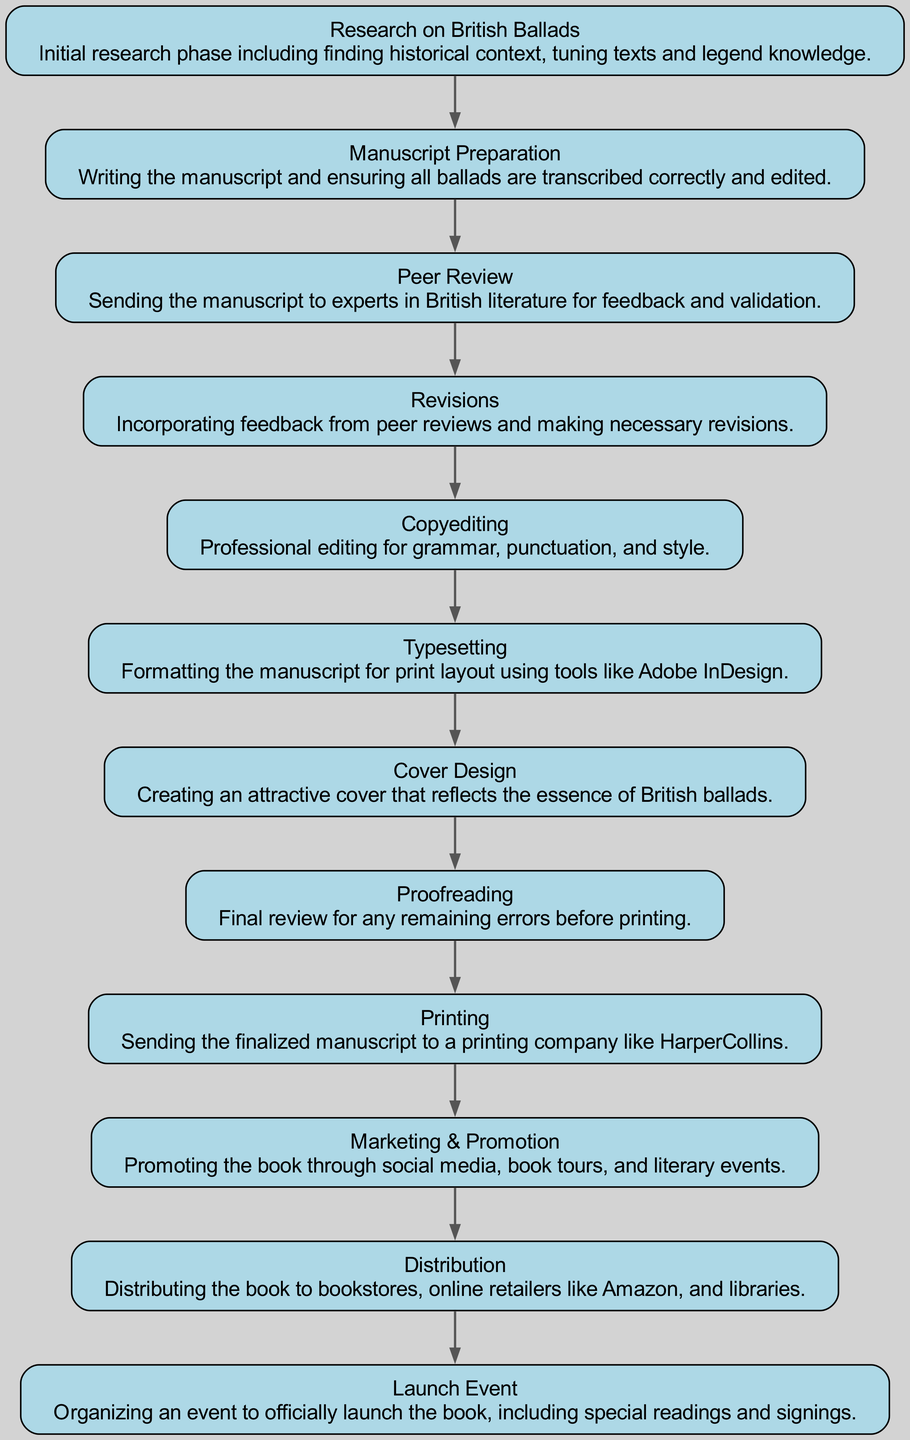What is the first step in the workflow? The diagram clearly indicates the first step as "Research on British Ballads," which is the starting point of the publishing process.
Answer: Research on British Ballads How many total steps are there in the workflow? By counting the nodes in the diagram, there are a total of 12 steps outlined in the publishing process.
Answer: 12 What follows "Manuscript Preparation" in the workflow? The diagram shows that "Peer Review" directly follows "Manuscript Preparation," indicating the next phase after completing the manuscript.
Answer: Peer Review What is the last step in the workflow? The diagram concludes with "Launch Event," identifying it as the final phase of the publishing process, where the book is officially launched.
Answer: Launch Event Which step is directly before "Proofreading"? The diagram indicates that "Copyediting" is the step directly preceding "Proofreading," as we move sequentially through the workflow.
Answer: Copyediting What is the relationship between "Revisions" and "Peer Review"? "Revisions" occurs after "Peer Review," showing that feedback received from peer reviewers leads to necessary changes in the manuscript.
Answer: Revisions after Peer Review How many editing stages are included in the workflow? The diagram presents two distinct editing stages: "Copyediting" and "Proofreading," which focus on different aspects of editing work.
Answer: 2 Which two steps focus primarily on preparing the book for print? The steps "Typesetting" and "Cover Design" are both focused on preparing the book visually and layout-wise for the print process.
Answer: Typesetting and Cover Design What is the main purpose of the "Marketing & Promotion" step? The diagram explains that the purpose of "Marketing & Promotion" is to enhance visibility and attract readers to the newly published book.
Answer: Enhance visibility 